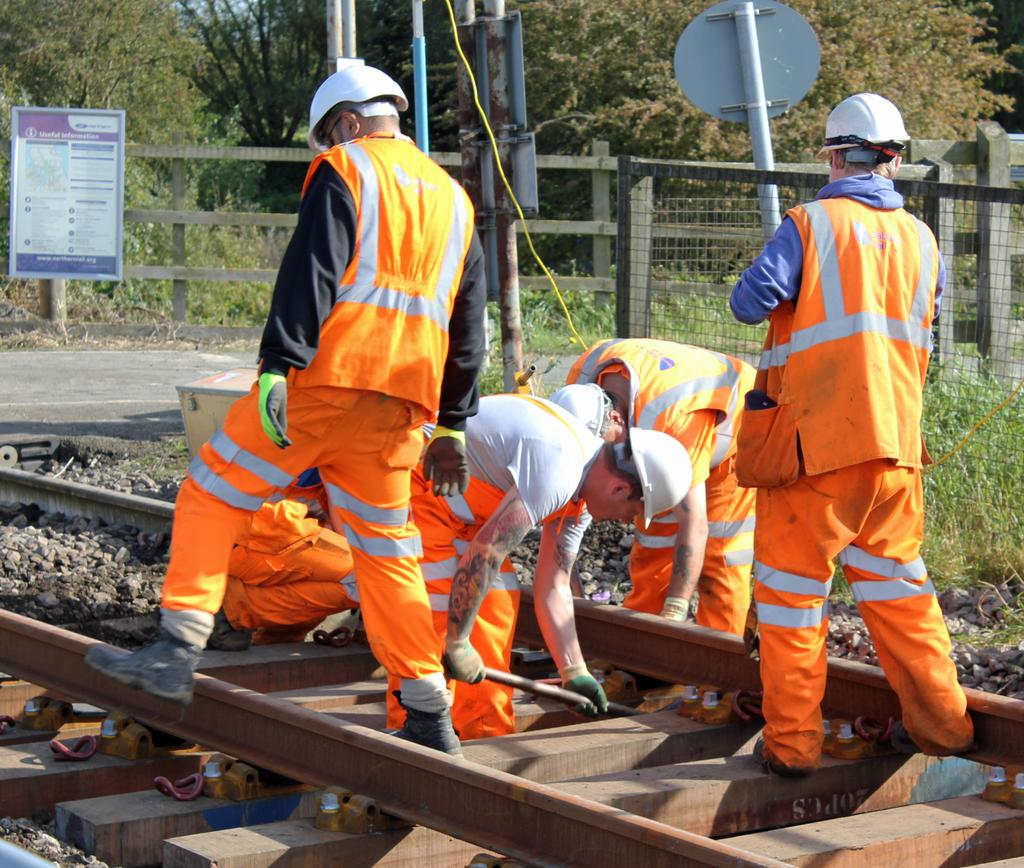What is happening on the track in the image? There is a group of men on the track in the image. What is one of the men holding? One man is holding a rod in the image. What type of natural elements can be seen in the image? There are stones, plants, and a group of trees visible in the image. What type of structures can be seen in the image? There are boards, poles, and a fence in the image. What type of print can be seen on the van in the image? There is no van present in the image; it features a group of men on a track with various structures and natural elements. 